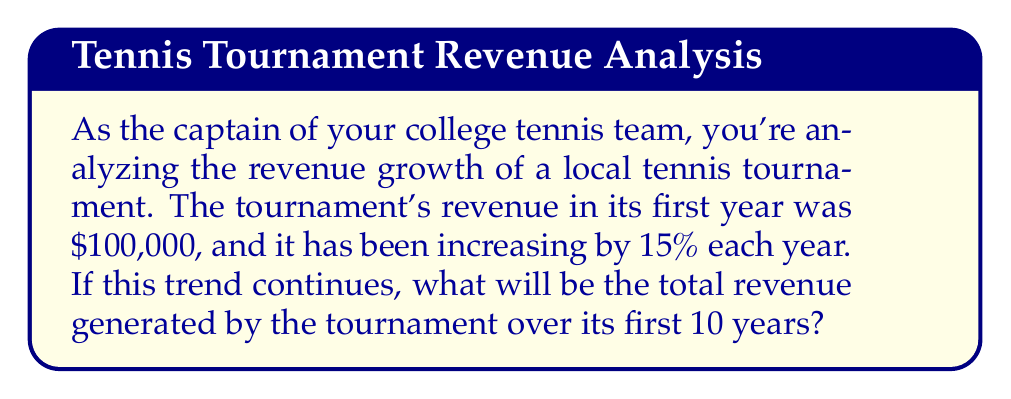Provide a solution to this math problem. Let's approach this step-by-step using the geometric series formula:

1) First, identify the components of the geometric series:
   - Initial term, $a = 100,000$
   - Common ratio, $r = 1.15$ (15% increase = 1 + 0.15)
   - Number of terms, $n = 10$ years

2) The formula for the sum of a geometric series is:
   $$S_n = \frac{a(1-r^n)}{1-r}$$
   where $S_n$ is the sum of the series, $a$ is the first term, $r$ is the common ratio, and $n$ is the number of terms.

3) Substitute the values into the formula:
   $$S_{10} = \frac{100,000(1-1.15^{10})}{1-1.15}$$

4) Calculate $1.15^{10}$:
   $1.15^{10} \approx 4.0456$

5) Substitute this value:
   $$S_{10} = \frac{100,000(1-4.0456)}{1-1.15} = \frac{100,000(-3.0456)}{-0.15}$$

6) Simplify:
   $$S_{10} = \frac{304,560}{0.15} = 2,030,400$$

Therefore, the total revenue generated over the first 10 years will be $2,030,400.
Answer: $2,030,400 